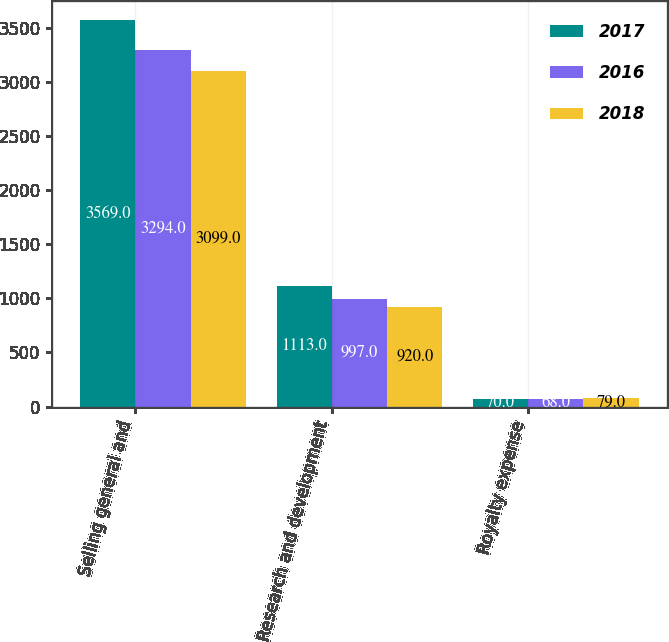<chart> <loc_0><loc_0><loc_500><loc_500><stacked_bar_chart><ecel><fcel>Selling general and<fcel>Research and development<fcel>Royalty expense<nl><fcel>2017<fcel>3569<fcel>1113<fcel>70<nl><fcel>2016<fcel>3294<fcel>997<fcel>68<nl><fcel>2018<fcel>3099<fcel>920<fcel>79<nl></chart> 